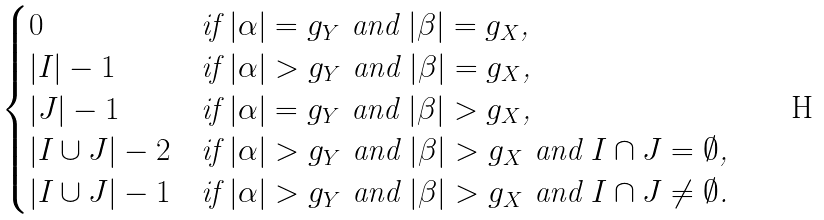Convert formula to latex. <formula><loc_0><loc_0><loc_500><loc_500>\begin{cases} 0 & \text {if $|\alpha|=g_{Y}$ and $|\beta|=g_{X}$,} \\ | I | - 1 & \text {if $|\alpha|>g_{Y}$ and $|\beta|=g_{X}$,} \\ | J | - 1 & \text {if $|\alpha|=g_{Y}$ and $|\beta|>g_{X}$,} \\ | I \cup J | - 2 & \text {if $|\alpha|>g_{Y}$ and $|\beta|>g_{X}$ and $I\cap J=\emptyset$,} \\ | I \cup J | - 1 & \text {if $|\alpha|>g_{Y}$ and $|\beta|>g_{X}$ and $I\cap J\neq\emptyset$.} \end{cases}</formula> 